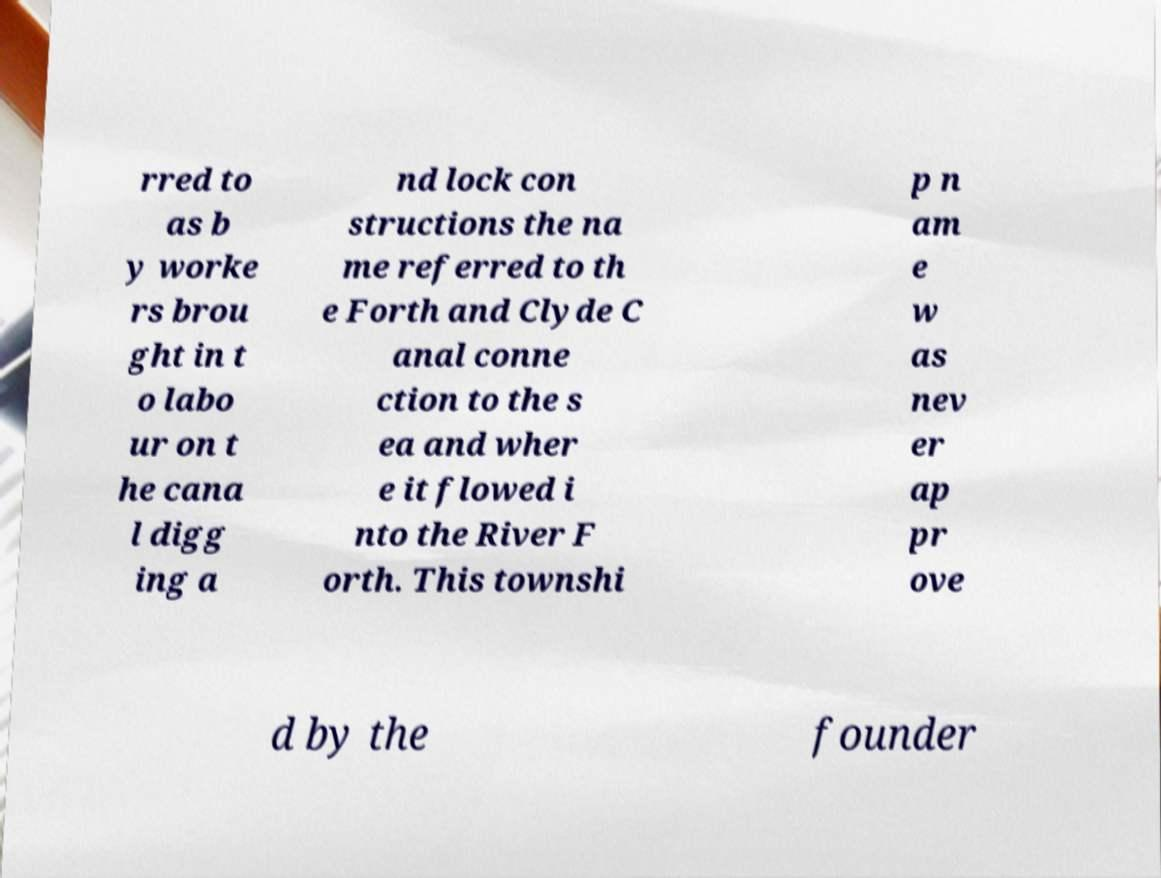Could you assist in decoding the text presented in this image and type it out clearly? rred to as b y worke rs brou ght in t o labo ur on t he cana l digg ing a nd lock con structions the na me referred to th e Forth and Clyde C anal conne ction to the s ea and wher e it flowed i nto the River F orth. This townshi p n am e w as nev er ap pr ove d by the founder 